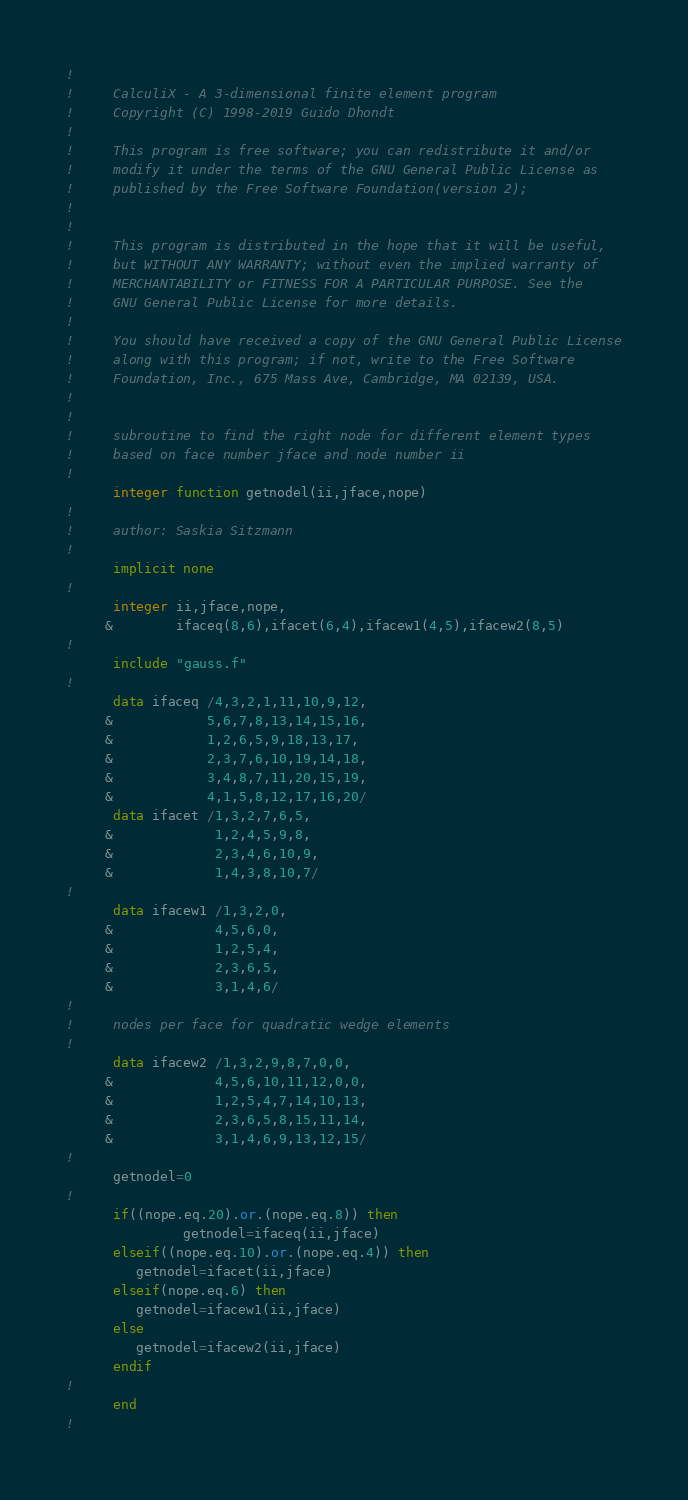<code> <loc_0><loc_0><loc_500><loc_500><_FORTRAN_>!     
!     CalculiX - A 3-dimensional finite element program
!     Copyright (C) 1998-2019 Guido Dhondt
!     
!     This program is free software; you can redistribute it and/or
!     modify it under the terms of the GNU General Public License as
!     published by the Free Software Foundation(version 2);
!     
!     
!     This program is distributed in the hope that it will be useful,
!     but WITHOUT ANY WARRANTY; without even the implied warranty of 
!     MERCHANTABILITY or FITNESS FOR A PARTICULAR PURPOSE. See the 
!     GNU General Public License for more details.
!     
!     You should have received a copy of the GNU General Public License
!     along with this program; if not, write to the Free Software
!     Foundation, Inc., 675 Mass Ave, Cambridge, MA 02139, USA.
!   
!
!     subroutine to find the right node for different element types 
!     based on face number jface and node number ii
!
      integer function getnodel(ii,jface,nope)
!
!     author: Saskia Sitzmann
!
      implicit none
!
      integer ii,jface,nope,
     &        ifaceq(8,6),ifacet(6,4),ifacew1(4,5),ifacew2(8,5)
!
      include "gauss.f"
!
      data ifaceq /4,3,2,1,11,10,9,12,
     &            5,6,7,8,13,14,15,16,
     &            1,2,6,5,9,18,13,17,
     &            2,3,7,6,10,19,14,18,
     &            3,4,8,7,11,20,15,19,
     &            4,1,5,8,12,17,16,20/
      data ifacet /1,3,2,7,6,5,
     &             1,2,4,5,9,8,
     &             2,3,4,6,10,9,
     &             1,4,3,8,10,7/
!
      data ifacew1 /1,3,2,0,
     &             4,5,6,0,
     &             1,2,5,4,
     &             2,3,6,5,
     &             3,1,4,6/
!
!     nodes per face for quadratic wedge elements
!
      data ifacew2 /1,3,2,9,8,7,0,0,
     &             4,5,6,10,11,12,0,0,
     &             1,2,5,4,7,14,10,13,
     &             2,3,6,5,8,15,11,14,
     &             3,1,4,6,9,13,12,15/
!     
      getnodel=0
!            
      if((nope.eq.20).or.(nope.eq.8)) then
               getnodel=ifaceq(ii,jface)
      elseif((nope.eq.10).or.(nope.eq.4)) then
         getnodel=ifacet(ii,jface)
      elseif(nope.eq.6) then
         getnodel=ifacew1(ii,jface)
      else
         getnodel=ifacew2(ii,jface)
      endif
!     
      end
!
</code> 